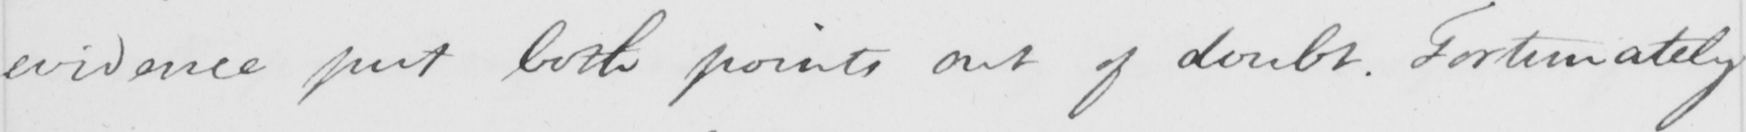Can you tell me what this handwritten text says? evidence put both points out of doubt . Fortunately 